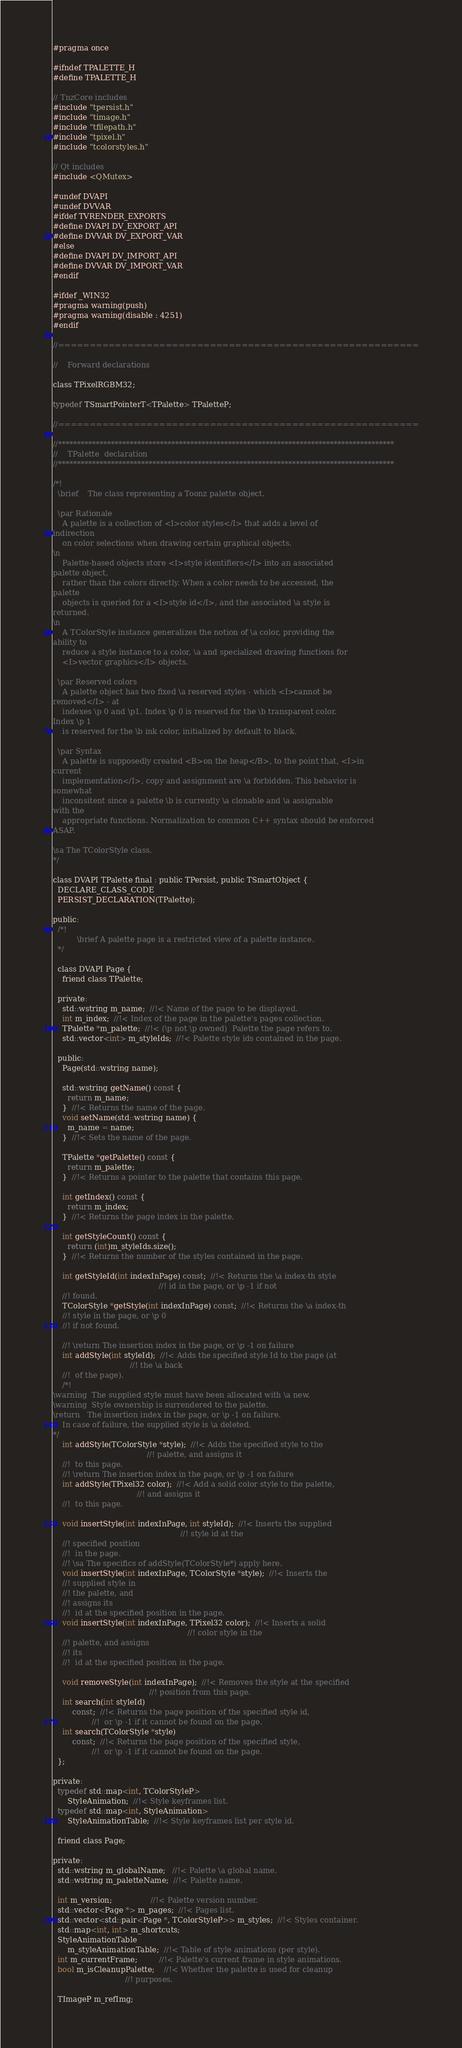<code> <loc_0><loc_0><loc_500><loc_500><_C_>#pragma once

#ifndef TPALETTE_H
#define TPALETTE_H

// TnzCore includes
#include "tpersist.h"
#include "timage.h"
#include "tfilepath.h"
#include "tpixel.h"
#include "tcolorstyles.h"

// Qt includes
#include <QMutex>

#undef DVAPI
#undef DVVAR
#ifdef TVRENDER_EXPORTS
#define DVAPI DV_EXPORT_API
#define DVVAR DV_EXPORT_VAR
#else
#define DVAPI DV_IMPORT_API
#define DVVAR DV_IMPORT_VAR
#endif

#ifdef _WIN32
#pragma warning(push)
#pragma warning(disable : 4251)
#endif

//=========================================================

//    Forward declarations

class TPixelRGBM32;

typedef TSmartPointerT<TPalette> TPaletteP;

//=========================================================

//*****************************************************************************************
//    TPalette  declaration
//*****************************************************************************************

/*!
  \brief    The class representing a Toonz palette object.

  \par Rationale
    A palette is a collection of <I>color styles</I> that adds a level of
indirection
    on color selections when drawing certain graphical objects.
\n
    Palette-based objects store <I>style identifiers</I> into an associated
palette object,
    rather than the colors directly. When a color needs to be accessed, the
palette
    objects is queried for a <I>style id</I>, and the associated \a style is
returned.
\n
    A TColorStyle instance generalizes the notion of \a color, providing the
ability to
    reduce a style instance to a color, \a and specialized drawing functions for
    <I>vector graphics</I> objects.

  \par Reserved colors
    A palette object has two fixed \a reserved styles - which <I>cannot be
removed</I> - at
    indexes \p 0 and \p1. Index \p 0 is reserved for the \b transparent color.
Index \p 1
    is reserved for the \b ink color, initialized by default to black.

  \par Syntax
    A palette is supposedly created <B>on the heap</B>, to the point that, <I>in
current
    implementation</I>, copy and assignment are \a forbidden. This behavior is
somewhat
    inconsitent since a palette \b is currently \a clonable and \a assignable
with the
    appropriate functions. Normalization to common C++ syntax should be enforced
ASAP.

\sa The TColorStyle class.
*/

class DVAPI TPalette final : public TPersist, public TSmartObject {
  DECLARE_CLASS_CODE
  PERSIST_DECLARATION(TPalette);

public:
  /*!
          \brief A palette page is a restricted view of a palette instance.
  */

  class DVAPI Page {
    friend class TPalette;

  private:
    std::wstring m_name;  //!< Name of the page to be displayed.
    int m_index;  //!< Index of the page in the palette's pages collection.
    TPalette *m_palette;  //!< (\p not \p owned)  Palette the page refers to.
    std::vector<int> m_styleIds;  //!< Palette style ids contained in the page.

  public:
    Page(std::wstring name);

    std::wstring getName() const {
      return m_name;
    }  //!< Returns the name of the page.
    void setName(std::wstring name) {
      m_name = name;
    }  //!< Sets the name of the page.

    TPalette *getPalette() const {
      return m_palette;
    }  //!< Returns a pointer to the palette that contains this page.

    int getIndex() const {
      return m_index;
    }  //!< Returns the page index in the palette.

    int getStyleCount() const {
      return (int)m_styleIds.size();
    }  //!< Returns the number of the styles contained in the page.

    int getStyleId(int indexInPage) const;  //!< Returns the \a index-th style
                                            //! id in the page, or \p -1 if not
    //! found.
    TColorStyle *getStyle(int indexInPage) const;  //!< Returns the \a index-th
    //! style in the page, or \p 0
    //! if not found.

    //! \return The insertion index in the page, or \p -1 on failure
    int addStyle(int styleId);  //!< Adds the specified style Id to the page (at
                                //! the \a back
    //!  of the page).
    /*!
\warning  The supplied style must have been allocated with \a new.
\warning  Style ownership is surrendered to the palette.
\return   The insertion index in the page, or \p -1 on failure.
    In case of failure, the supplied style is \a deleted.
*/
    int addStyle(TColorStyle *style);  //!< Adds the specified style to the
                                       //! palette, and assigns it
    //!  to this page.
    //! \return The insertion index in the page, or \p -1 on failure
    int addStyle(TPixel32 color);  //!< Add a solid color style to the palette,
                                   //! and assigns it
    //!  to this page.

    void insertStyle(int indexInPage, int styleId);  //!< Inserts the supplied
                                                     //! style id at the
    //! specified position
    //!  in the page.
    //! \sa The specifics of addStyle(TColorStyle*) apply here.
    void insertStyle(int indexInPage, TColorStyle *style);  //!< Inserts the
    //! supplied style in
    //! the palette, and
    //! assigns its
    //!  id at the specified position in the page.
    void insertStyle(int indexInPage, TPixel32 color);  //!< Inserts a solid
                                                        //! color style in the
    //! palette, and assigns
    //! its
    //!  id at the specified position in the page.

    void removeStyle(int indexInPage);  //!< Removes the style at the specified
                                        //! position from this page.
    int search(int styleId)
        const;  //!< Returns the page position of the specified style id,
                //!  or \p -1 if it cannot be found on the page.
    int search(TColorStyle *style)
        const;  //!< Returns the page position of the specified style,
                //!  or \p -1 if it cannot be found on the page.
  };

private:
  typedef std::map<int, TColorStyleP>
      StyleAnimation;  //!< Style keyframes list.
  typedef std::map<int, StyleAnimation>
      StyleAnimationTable;  //!< Style keyframes list per style id.

  friend class Page;

private:
  std::wstring m_globalName;   //!< Palette \a global name.
  std::wstring m_paletteName;  //!< Palette name.

  int m_version;                //!< Palette version number.
  std::vector<Page *> m_pages;  //!< Pages list.
  std::vector<std::pair<Page *, TColorStyleP>> m_styles;  //!< Styles container.
  std::map<int, int> m_shortcuts;
  StyleAnimationTable
      m_styleAnimationTable;  //!< Table of style animations (per style).
  int m_currentFrame;         //!< Palette's current frame in style animations.
  bool m_isCleanupPalette;    //!< Whether the palette is used for cleanup
                              //! purposes.

  TImageP m_refImg;</code> 